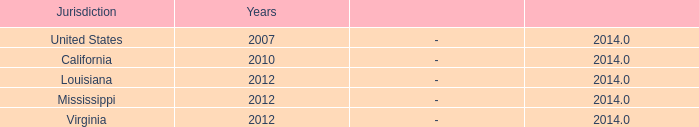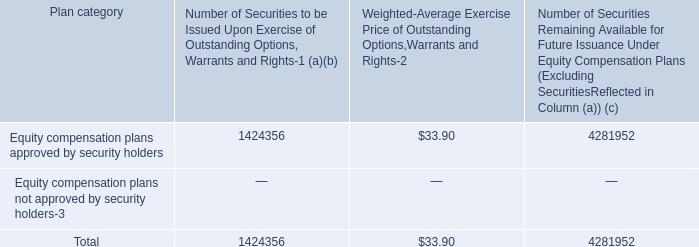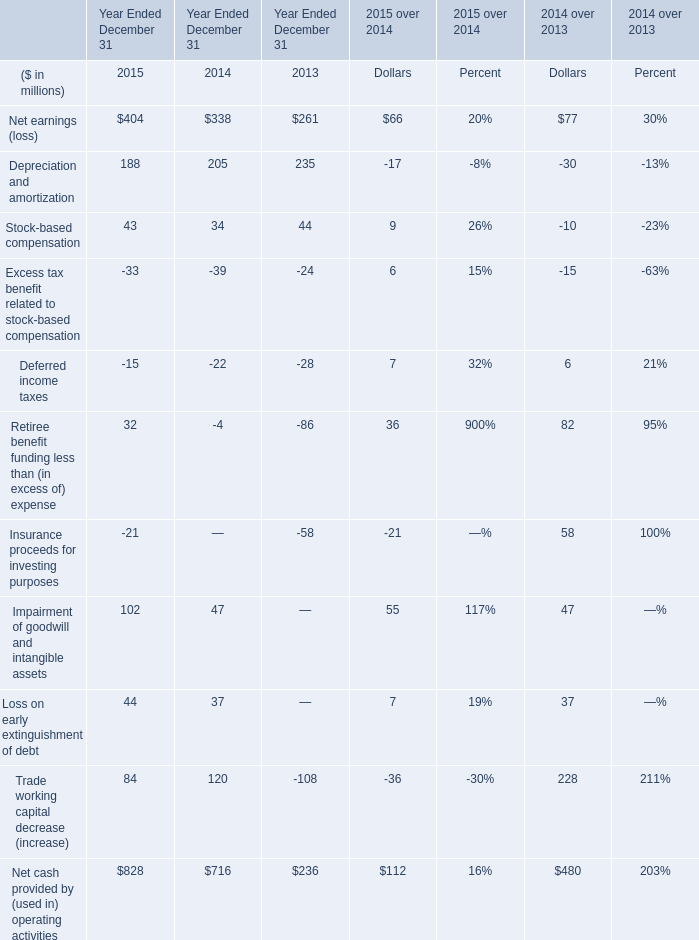What was the average value of Depreciation and amortization, Stock-based compensation, Excess tax benefit related to stock-based compensation in2015? (in million) 
Computations: (((188 + 43) - 33) / 3)
Answer: 66.0. 